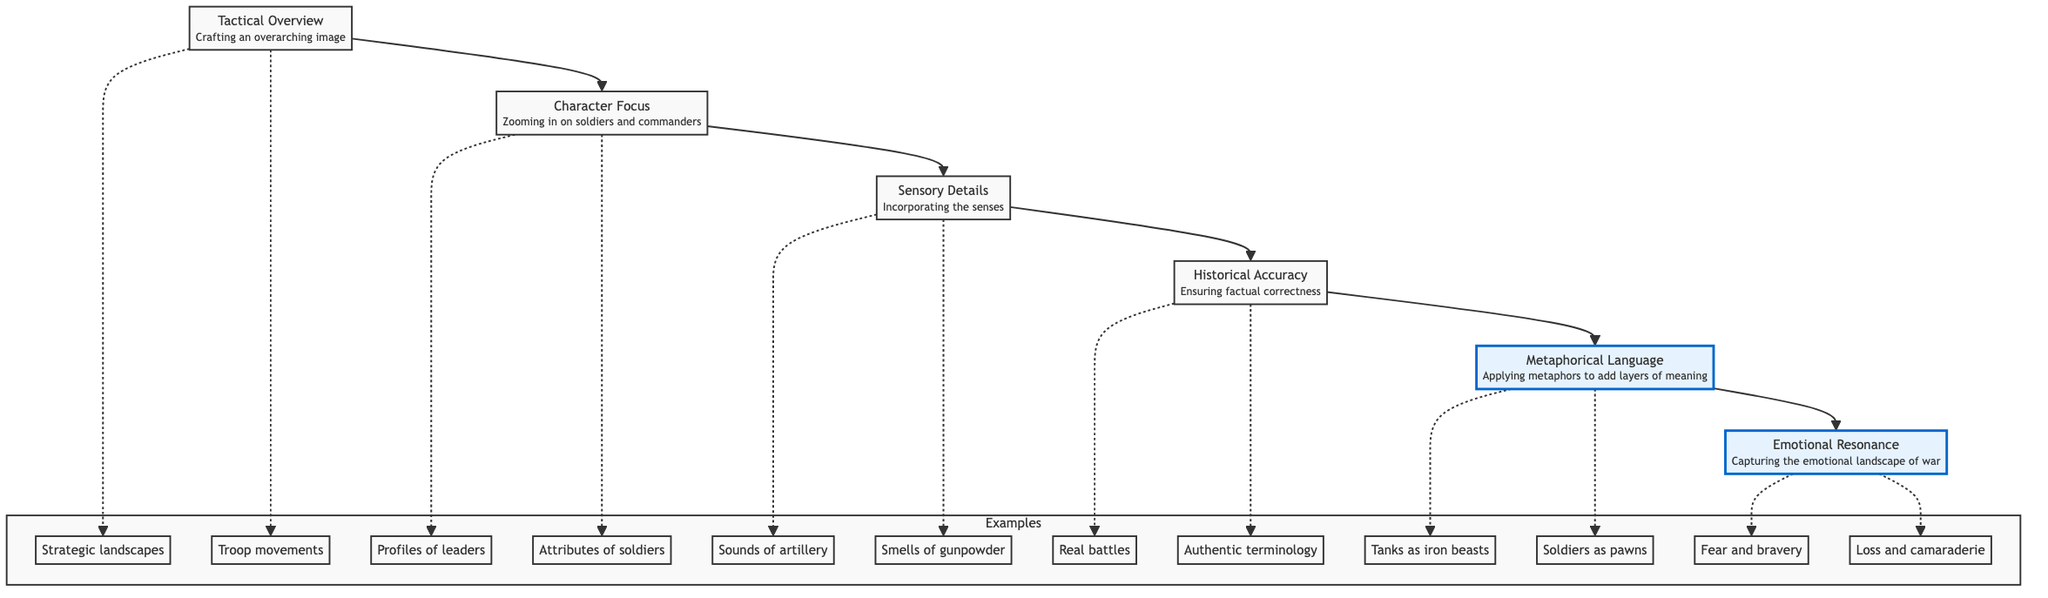What is the top node in the diagram? The top node represents the culminating aspect of developing imagery, which is "Emotional Resonance." It captures the essence of the emotional landscape of war poetry.
Answer: Emotional Resonance How many nodes are there in the diagram? The diagram consists of six main nodes: Tactical Overview, Character Focus, Sensory Details, Historical Accuracy, Metaphorical Language, and Emotional Resonance.
Answer: 6 What is the relationship between Tactical Overview and Character Focus? Tactical Overview is the first step in the flow, leading directly to Character Focus, indicating that a comprehensive view of the battlefield sets the stage for zooming in on individual soldiers and leaders.
Answer: Tactical Overview leads to Character Focus Which node focuses on the emotional aspects of war? The node that addresses the emotional aspects of war poetry is "Emotional Resonance," which captures feelings such as fear, bravery, loss, and camaraderie.
Answer: Emotional Resonance What type of language is applied in the node before Emotional Resonance? The node that precedes Emotional Resonance is "Metaphorical Language," which adds layers of meaning through metaphorical expressions related to war.
Answer: Metaphorical Language Which examples are associated with Sensory Details? Sensory Details include examples such as "Sounds of artillery fire" and "Smells of gunpowder," which help to deepen the imagery through sensory experiences.
Answer: Sounds of artillery fire, Smells of gunpowder What is the flow direction of the diagram? The flow direction is from bottom to top, showing a progression from Tactical Overview through various elements to Emotional Resonance at the top.
Answer: Bottom to top What is the second to last node in the flow? The second to last node before reaching the peak of Emotional Resonance is "Metaphorical Language," which contributes depth to the imagery developed from prior nodes.
Answer: Metaphorical Language How is Historical Accuracy related to Sensory Details? Historical Accuracy supports the factual basis of the imagery, ensuring that the Sensory Details resonate with reality, thereby enhancing the overall credibility of the poetry.
Answer: Historical Accuracy supports Sensory Details 